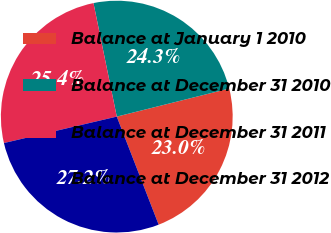Convert chart to OTSL. <chart><loc_0><loc_0><loc_500><loc_500><pie_chart><fcel>Balance at January 1 2010<fcel>Balance at December 31 2010<fcel>Balance at December 31 2011<fcel>Balance at December 31 2012<nl><fcel>23.01%<fcel>24.33%<fcel>25.44%<fcel>27.22%<nl></chart> 